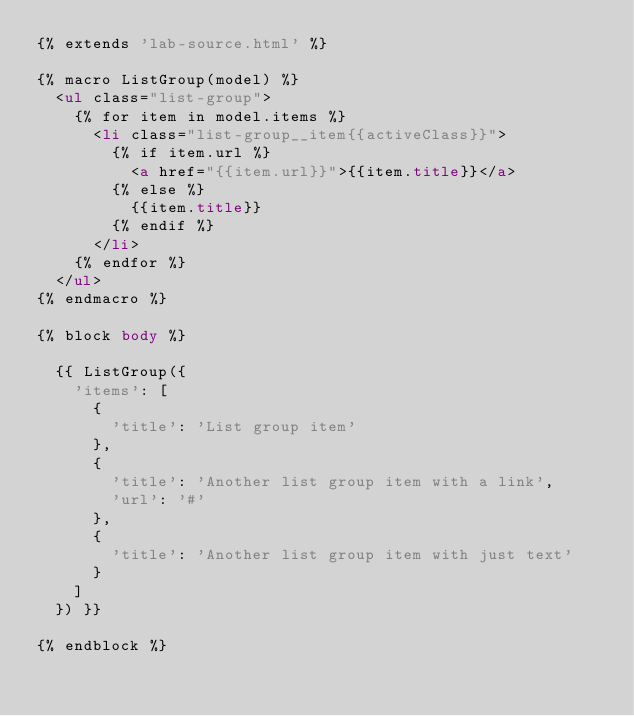<code> <loc_0><loc_0><loc_500><loc_500><_HTML_>{% extends 'lab-source.html' %}

{% macro ListGroup(model) %}
  <ul class="list-group">
    {% for item in model.items %}
      <li class="list-group__item{{activeClass}}">
        {% if item.url %}
          <a href="{{item.url}}">{{item.title}}</a>
        {% else %}
          {{item.title}}
        {% endif %}
      </li>
    {% endfor %}
  </ul>
{% endmacro %}

{% block body %}

  {{ ListGroup({
    'items': [
      {
        'title': 'List group item'
      },
      {
        'title': 'Another list group item with a link',
        'url': '#'
      },
      {
        'title': 'Another list group item with just text'
      }
    ]
  }) }}

{% endblock %}
</code> 